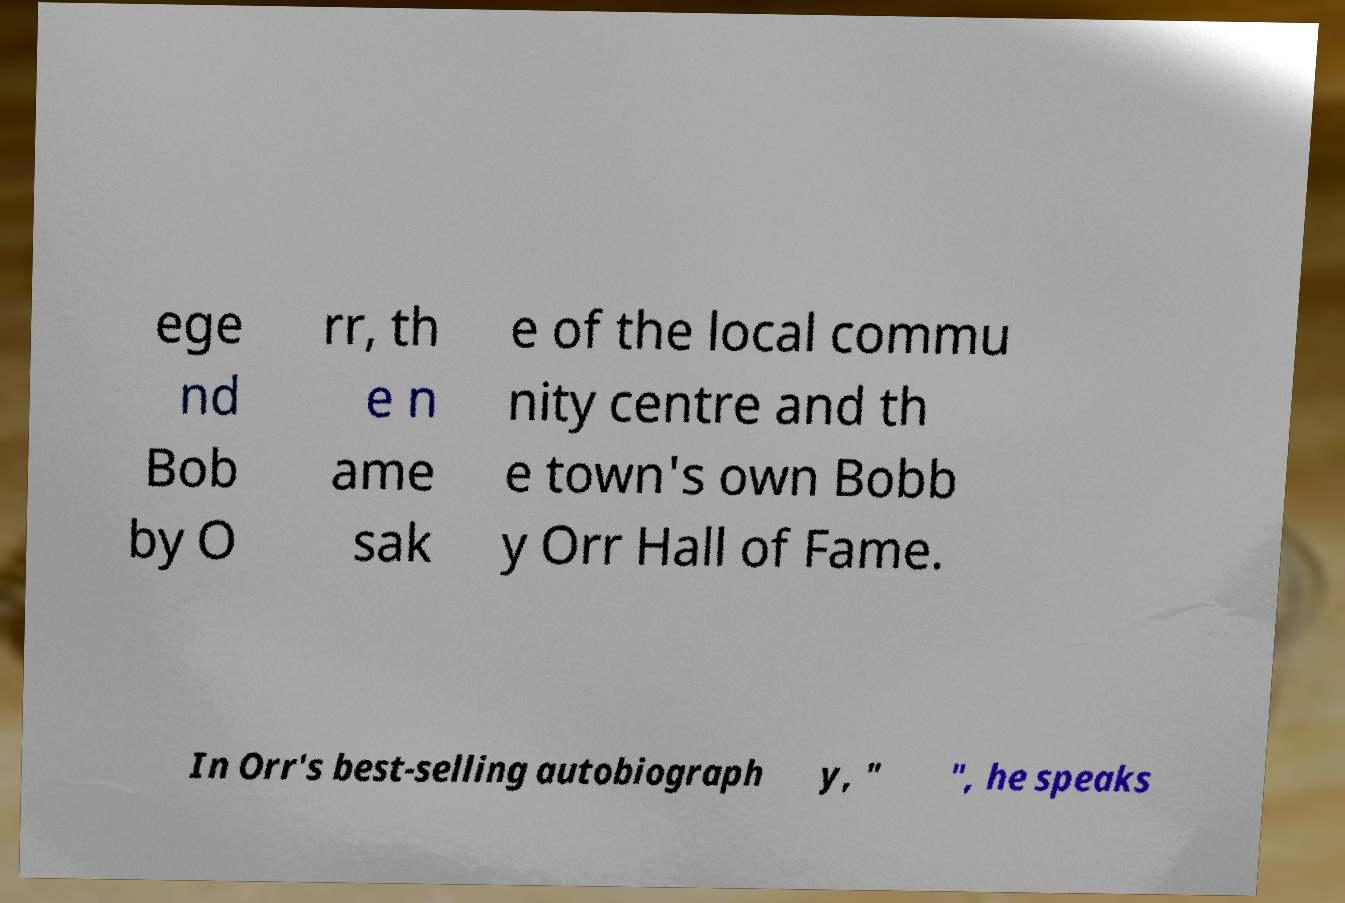Can you read and provide the text displayed in the image?This photo seems to have some interesting text. Can you extract and type it out for me? ege nd Bob by O rr, th e n ame sak e of the local commu nity centre and th e town's own Bobb y Orr Hall of Fame. In Orr's best-selling autobiograph y, " ", he speaks 